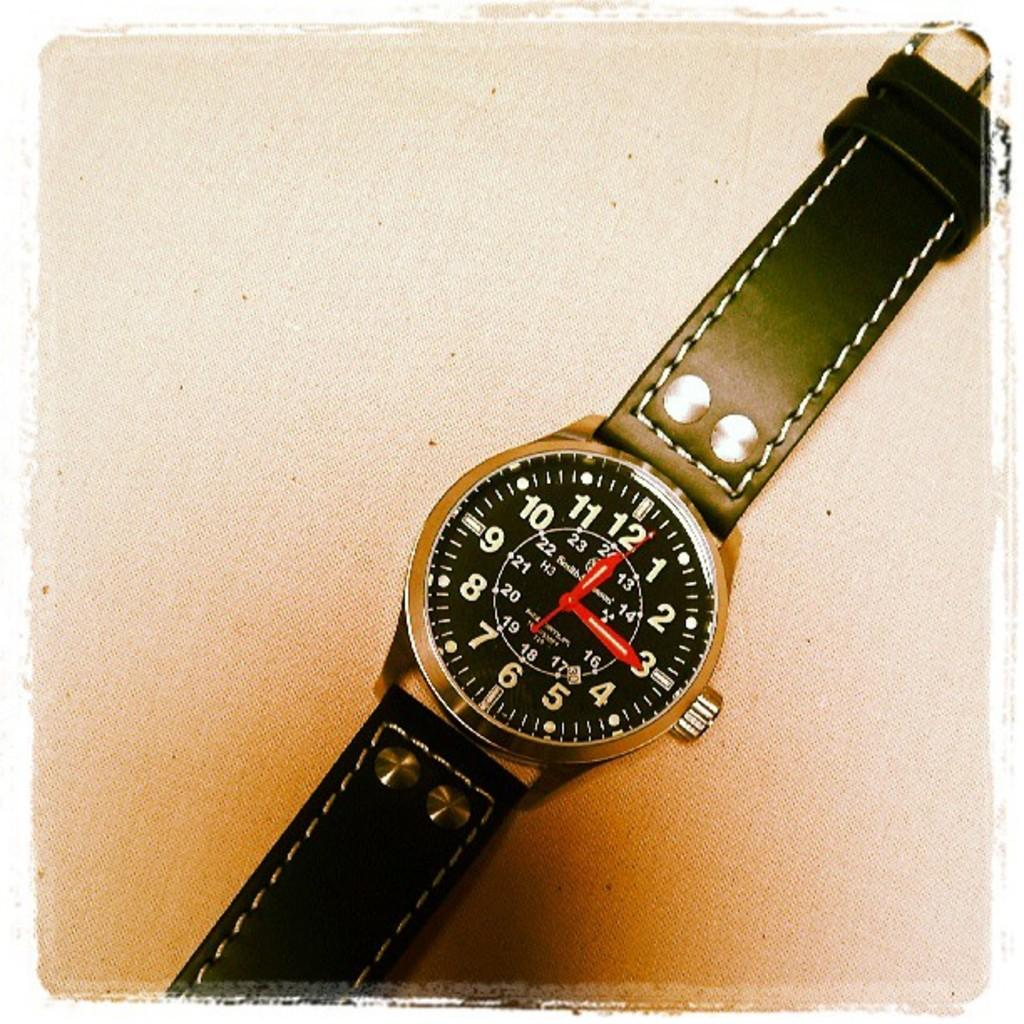<image>
Write a terse but informative summary of the picture. A watch has the number 30 in the little date window by the number 5. 